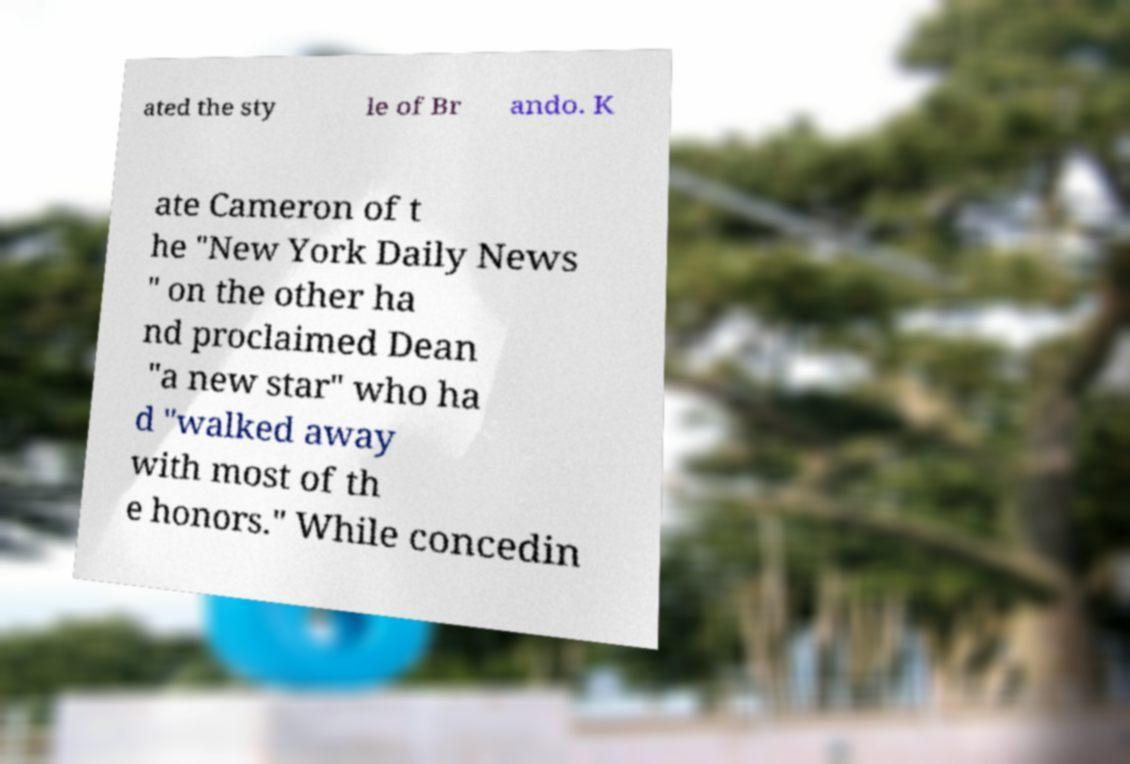Could you assist in decoding the text presented in this image and type it out clearly? ated the sty le of Br ando. K ate Cameron of t he "New York Daily News " on the other ha nd proclaimed Dean "a new star" who ha d "walked away with most of th e honors." While concedin 